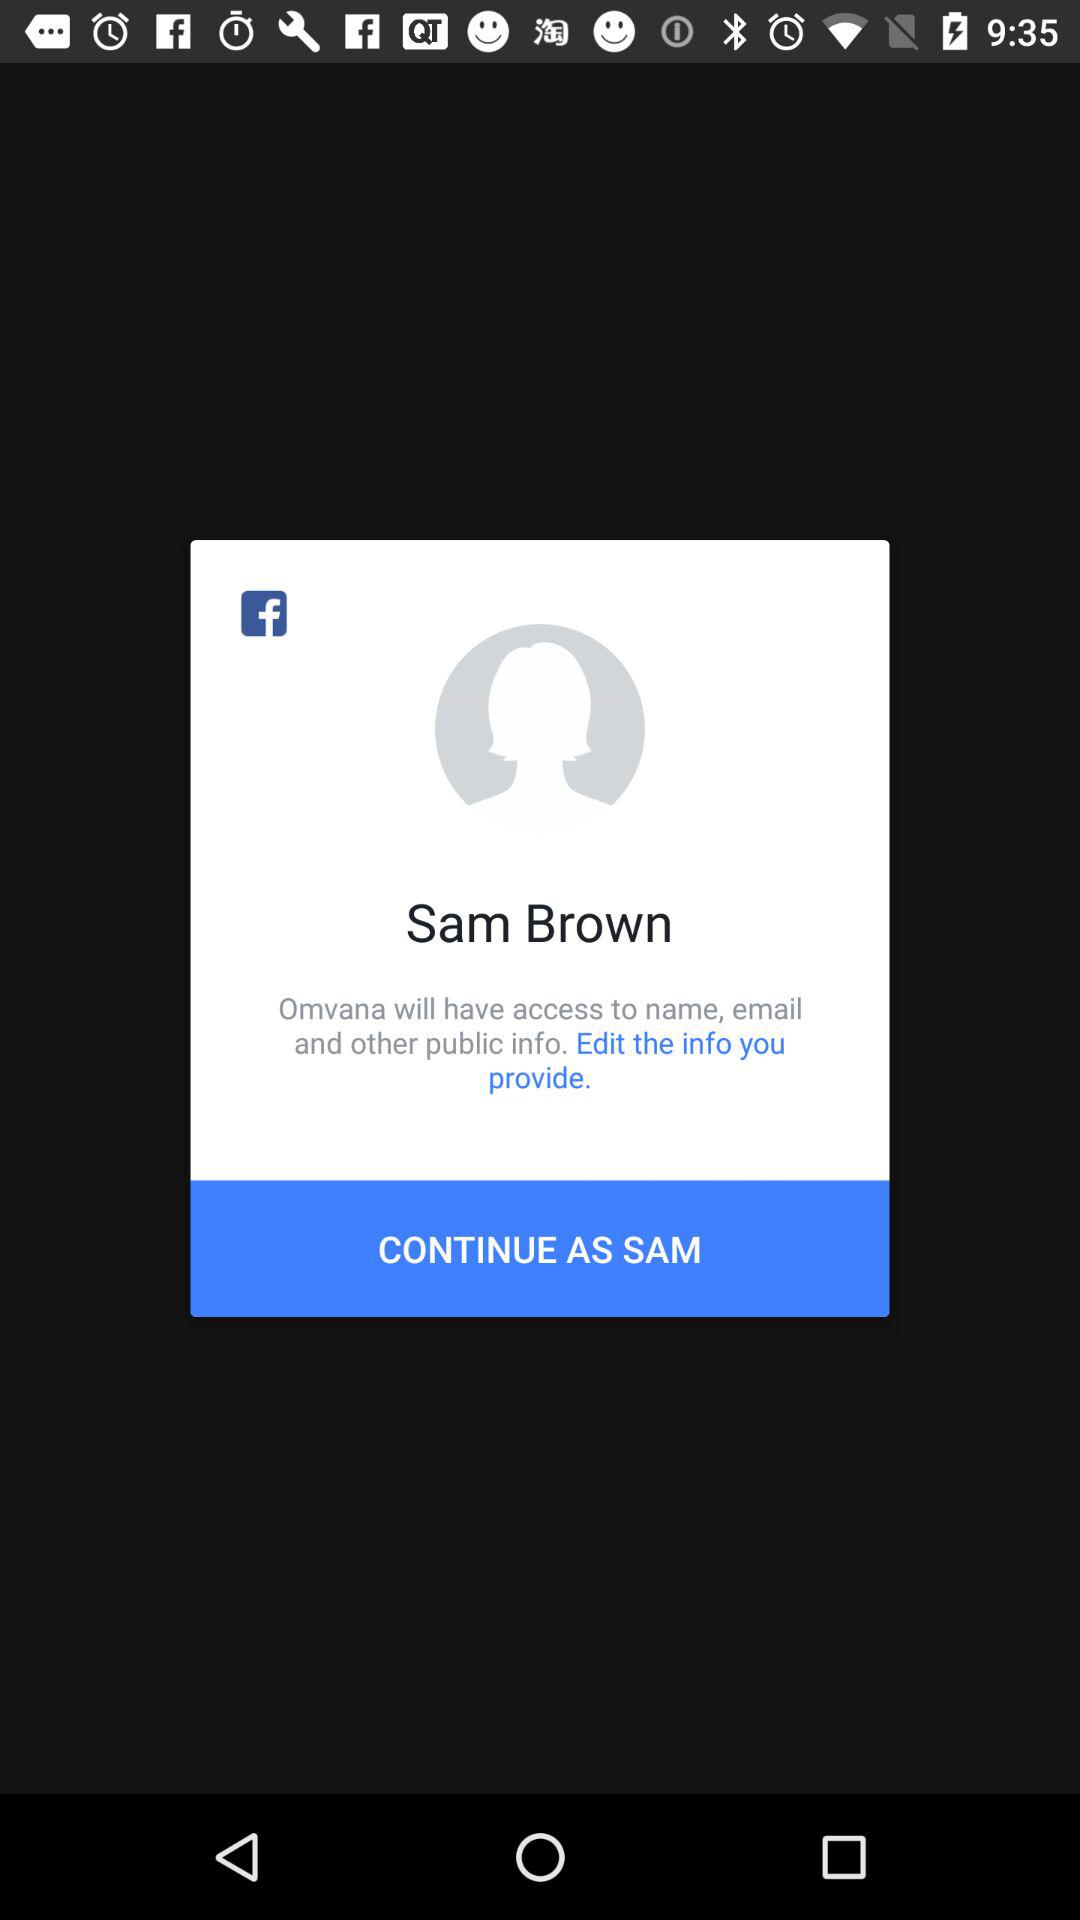What application can be used to continue? The application that can be used to continue is "Facebook". 